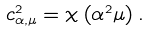<formula> <loc_0><loc_0><loc_500><loc_500>c _ { \alpha , \mu } ^ { 2 } = \chi \left ( \alpha ^ { 2 } \mu \right ) .</formula> 